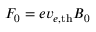Convert formula to latex. <formula><loc_0><loc_0><loc_500><loc_500>F _ { 0 } = e v _ { e , { t h } } B _ { 0 }</formula> 